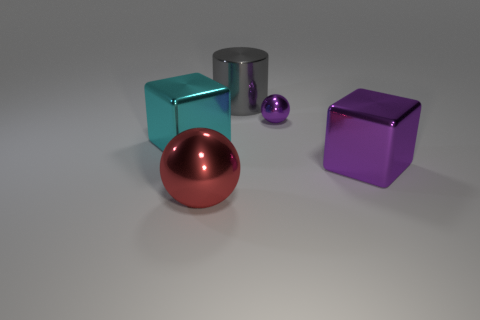How many other things are made of the same material as the small purple object?
Make the answer very short. 4. What is the material of the red thing that is the same size as the gray cylinder?
Provide a short and direct response. Metal. Does the big shiny thing that is behind the purple shiny sphere have the same shape as the shiny thing to the left of the red ball?
Offer a very short reply. No. The cyan thing that is the same size as the red thing is what shape?
Ensure brevity in your answer.  Cube. Does the large block that is on the right side of the large gray cylinder have the same material as the purple object behind the big cyan object?
Provide a short and direct response. Yes. There is a shiny cube that is to the right of the gray metal cylinder; is there a gray shiny cylinder that is right of it?
Give a very brief answer. No. There is a small object that is the same material as the large purple block; what is its color?
Provide a short and direct response. Purple. Is the number of small red rubber objects greater than the number of big gray cylinders?
Offer a very short reply. No. How many things are either big cubes right of the big cylinder or spheres?
Give a very brief answer. 3. Are there any other objects that have the same size as the red thing?
Your response must be concise. Yes. 